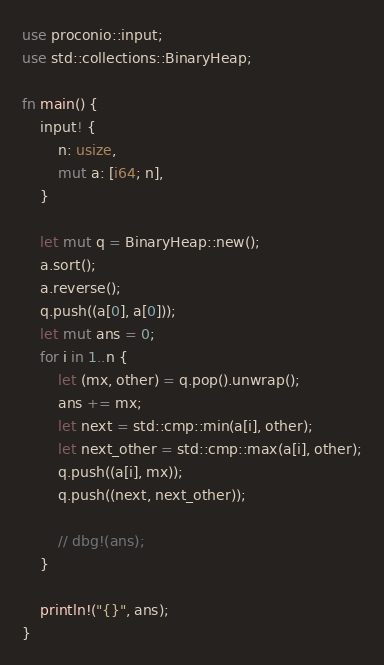<code> <loc_0><loc_0><loc_500><loc_500><_Rust_>use proconio::input;
use std::collections::BinaryHeap;

fn main() {
    input! {
        n: usize,
        mut a: [i64; n],
    }

    let mut q = BinaryHeap::new();
    a.sort();
    a.reverse();
    q.push((a[0], a[0]));
    let mut ans = 0;
    for i in 1..n {
        let (mx, other) = q.pop().unwrap();
        ans += mx;
        let next = std::cmp::min(a[i], other);
        let next_other = std::cmp::max(a[i], other);
        q.push((a[i], mx));
        q.push((next, next_other));

        // dbg!(ans);
    }

    println!("{}", ans);
}
</code> 